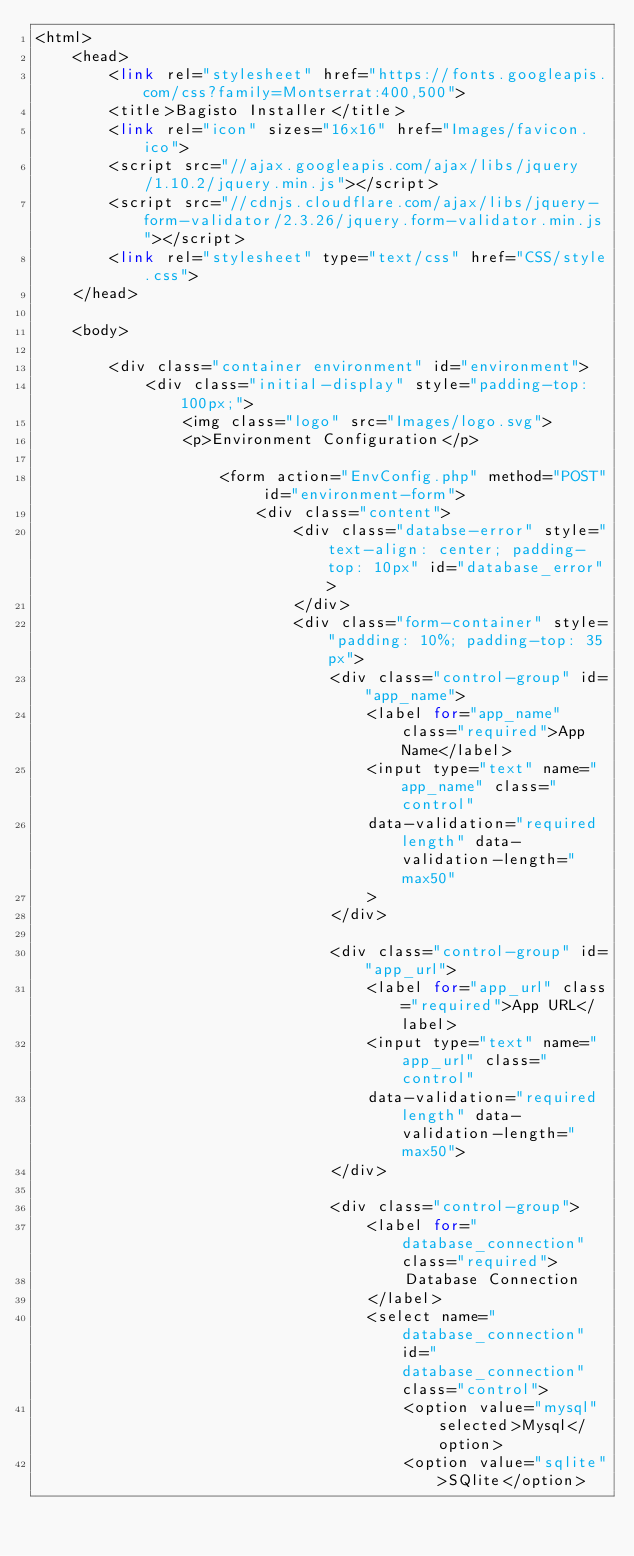<code> <loc_0><loc_0><loc_500><loc_500><_PHP_><html>
    <head>
        <link rel="stylesheet" href="https://fonts.googleapis.com/css?family=Montserrat:400,500">
        <title>Bagisto Installer</title>
        <link rel="icon" sizes="16x16" href="Images/favicon.ico">
        <script src="//ajax.googleapis.com/ajax/libs/jquery/1.10.2/jquery.min.js"></script>
        <script src="//cdnjs.cloudflare.com/ajax/libs/jquery-form-validator/2.3.26/jquery.form-validator.min.js"></script>
        <link rel="stylesheet" type="text/css" href="CSS/style.css">
    </head>

    <body>

        <div class="container environment" id="environment">
            <div class="initial-display" style="padding-top: 100px;">
                <img class="logo" src="Images/logo.svg">
                <p>Environment Configuration</p>

                    <form action="EnvConfig.php" method="POST" id="environment-form">
                        <div class="content">
                            <div class="databse-error" style="text-align: center; padding-top: 10px" id="database_error">
                            </div>
                            <div class="form-container" style="padding: 10%; padding-top: 35px">
                                <div class="control-group" id="app_name">
                                    <label for="app_name" class="required">App Name</label>
                                    <input type="text" name="app_name" class="control"
                                    data-validation="required length" data-validation-length="max50"
                                    >
                                </div>

                                <div class="control-group" id="app_url">
                                    <label for="app_url" class="required">App URL</label>
                                    <input type="text" name="app_url" class="control"
                                    data-validation="required length" data-validation-length="max50">
                                </div>

                                <div class="control-group">
                                    <label for="database_connection" class="required">
                                        Database Connection
                                    </label>
                                    <select name="database_connection" id="database_connection" class="control">
                                        <option value="mysql" selected>Mysql</option>
                                        <option value="sqlite">SQlite</option></code> 